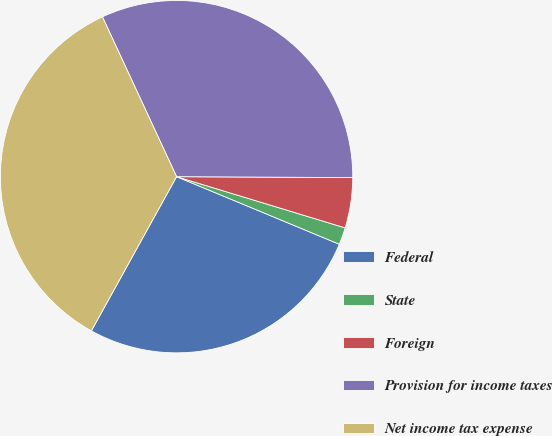<chart> <loc_0><loc_0><loc_500><loc_500><pie_chart><fcel>Federal<fcel>State<fcel>Foreign<fcel>Provision for income taxes<fcel>Net income tax expense<nl><fcel>26.77%<fcel>1.57%<fcel>4.61%<fcel>32.0%<fcel>35.05%<nl></chart> 